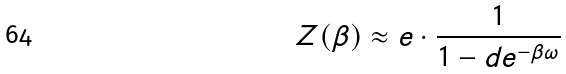<formula> <loc_0><loc_0><loc_500><loc_500>Z ( \beta ) \approx e \cdot \frac { 1 } { 1 - d e ^ { - \beta \omega } }</formula> 